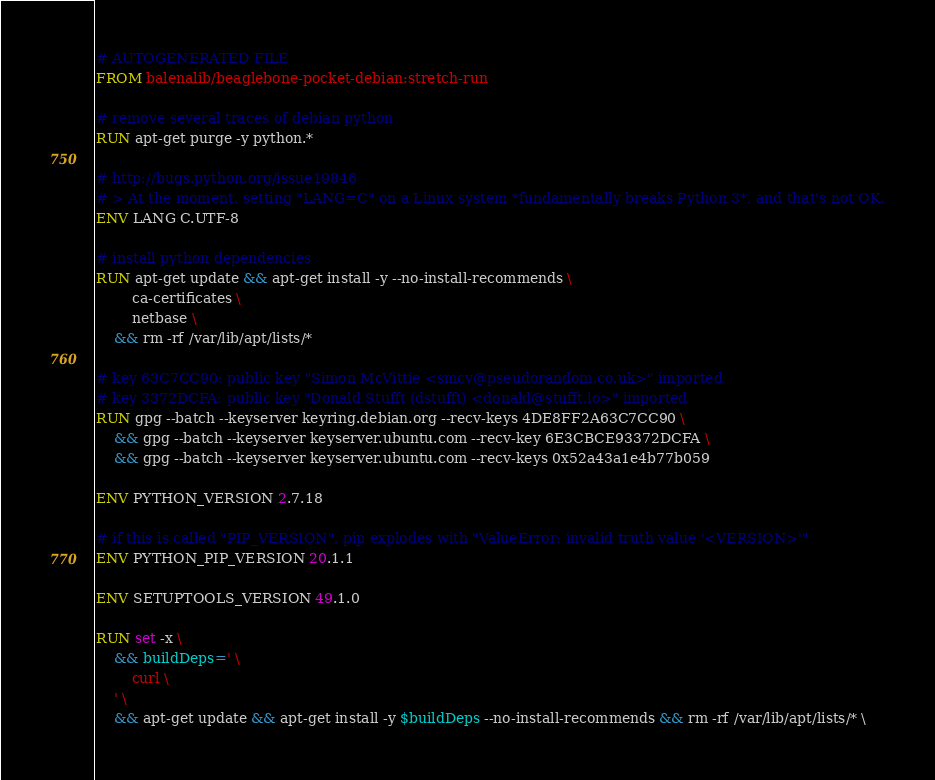Convert code to text. <code><loc_0><loc_0><loc_500><loc_500><_Dockerfile_># AUTOGENERATED FILE
FROM balenalib/beaglebone-pocket-debian:stretch-run

# remove several traces of debian python
RUN apt-get purge -y python.*

# http://bugs.python.org/issue19846
# > At the moment, setting "LANG=C" on a Linux system *fundamentally breaks Python 3*, and that's not OK.
ENV LANG C.UTF-8

# install python dependencies
RUN apt-get update && apt-get install -y --no-install-recommends \
		ca-certificates \
		netbase \
	&& rm -rf /var/lib/apt/lists/*

# key 63C7CC90: public key "Simon McVittie <smcv@pseudorandom.co.uk>" imported
# key 3372DCFA: public key "Donald Stufft (dstufft) <donald@stufft.io>" imported
RUN gpg --batch --keyserver keyring.debian.org --recv-keys 4DE8FF2A63C7CC90 \
	&& gpg --batch --keyserver keyserver.ubuntu.com --recv-key 6E3CBCE93372DCFA \
	&& gpg --batch --keyserver keyserver.ubuntu.com --recv-keys 0x52a43a1e4b77b059

ENV PYTHON_VERSION 2.7.18

# if this is called "PIP_VERSION", pip explodes with "ValueError: invalid truth value '<VERSION>'"
ENV PYTHON_PIP_VERSION 20.1.1

ENV SETUPTOOLS_VERSION 49.1.0

RUN set -x \
	&& buildDeps=' \
		curl \
	' \
	&& apt-get update && apt-get install -y $buildDeps --no-install-recommends && rm -rf /var/lib/apt/lists/* \</code> 